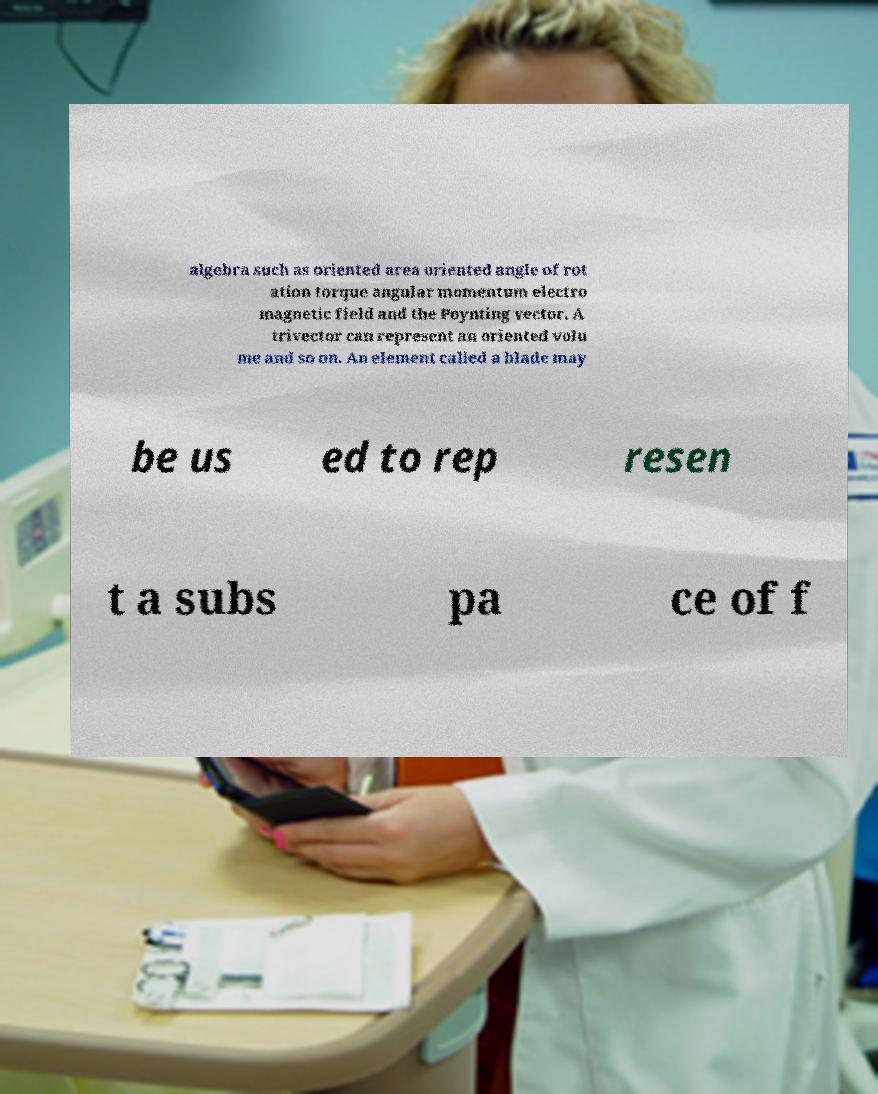I need the written content from this picture converted into text. Can you do that? algebra such as oriented area oriented angle of rot ation torque angular momentum electro magnetic field and the Poynting vector. A trivector can represent an oriented volu me and so on. An element called a blade may be us ed to rep resen t a subs pa ce of f 